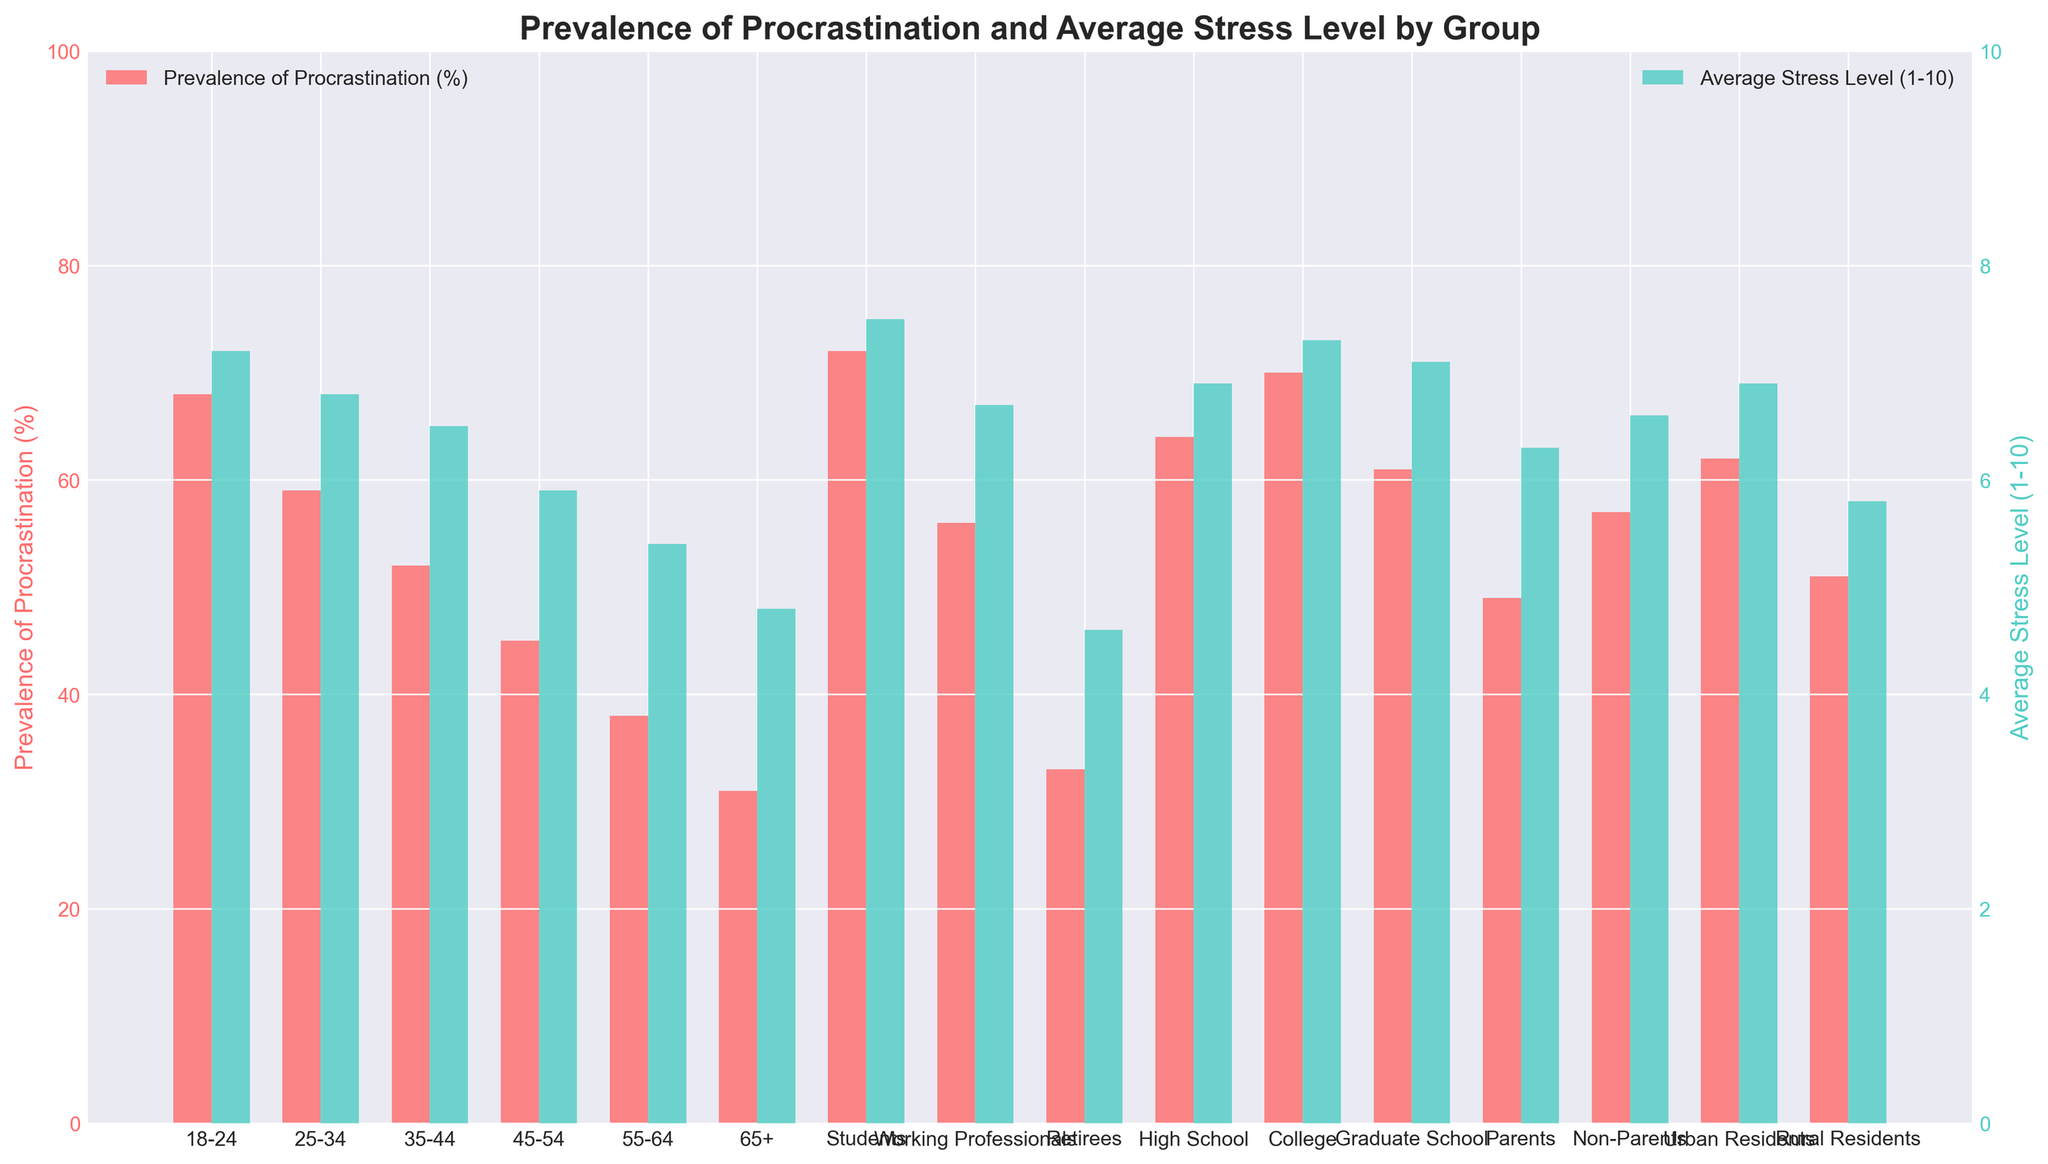What is the prevalence of procrastination among students? The red bar representing the prevalence of procrastination among students is the highest and reaches 72% on the left y-axis.
Answer: 72% Which age group has the highest average stress level? The turquoise bar representing the average stress level is highest for the "College" group, reaching just above 7.3 on the right y-axis.
Answer: College Compare the prevalence of procrastination between urban and rural residents. The height of the red bar for urban residents is higher than the red bar for rural residents; urban residents have a prevalence of 62%, while rural residents have a prevalence of 51%.
Answer: Urban residents have a higher prevalence What is the difference in average stress level between 18-24 and 65+ age groups? The turquoise bar for the 18-24 age group is at 7.2 on the right y-axis, and for the 65+ age group, it is at 4.8, giving a difference of 7.2 - 4.8 = 2.4.
Answer: 2.4 Which group has a higher prevalence of procrastination: Parents or Non-Parents? The height of the red bar for Non-Parents is higher than that for Parents; Non-Parents have a prevalence of 57%, while Parents have a prevalence of 49%.
Answer: Non-Parents What is the combined prevalence of procrastination for the age groups 18-24 and 25-34? The red bars for the 18-24 and 25-34 age groups are at 68% and 59%, respectively. Adding them gives 68 + 59 = 127.
Answer: 127% What is the average prevalence of procrastination across the age groups (18-24, 25-34, 35-44, 45-54, 55-64, 65+)? Summing the prevalence values for the age groups: 68 + 59 + 52 + 45 + 38 + 31 = 293. Dividing by 6 (number of age groups): 293 / 6 ≈ 48.8.
Answer: 48.8% How does the average stress level of Graduate School students compare to that of High School students? The turquoise bar for Graduate School students is at 7.1, while the bar for High School students is at 6.9. Therefore, Graduate School students have a slightly higher average stress level.
Answer: Graduate School students have a higher average stress level Which group has the lowest average stress level? The shortest turquoise bar represents the Retirees, showing an average stress level of 4.6.
Answer: Retirees What is the prevalence of procrastination among the 35-44 age group, and how does it compare with working professionals? The red bars indicate that the prevalence for the 35-44 age group is 52%, and for working professionals, it is 56%. Thus, the prevalence is slightly lower for the 35-44 age group.
Answer: 52%, lower 